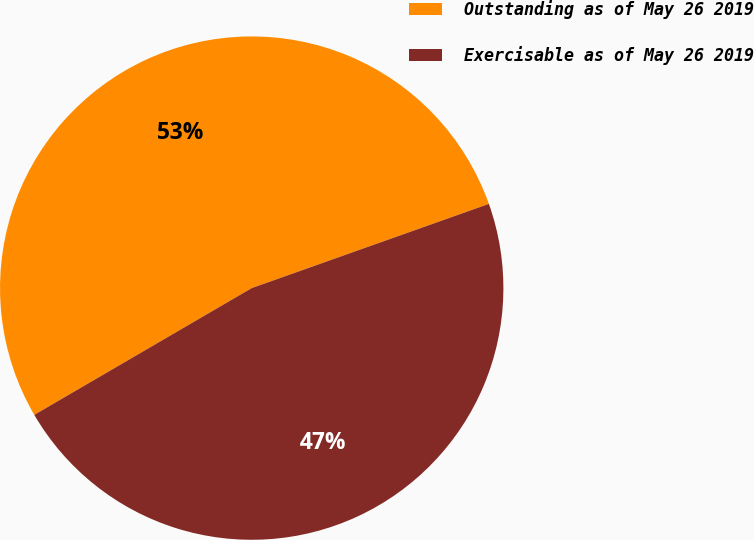<chart> <loc_0><loc_0><loc_500><loc_500><pie_chart><fcel>Outstanding as of May 26 2019<fcel>Exercisable as of May 26 2019<nl><fcel>52.97%<fcel>47.03%<nl></chart> 